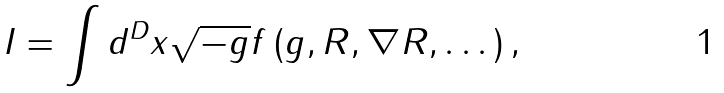<formula> <loc_0><loc_0><loc_500><loc_500>I = \int d ^ { D } x \sqrt { - g } f \left ( g , R , \nabla R , \dots \right ) ,</formula> 